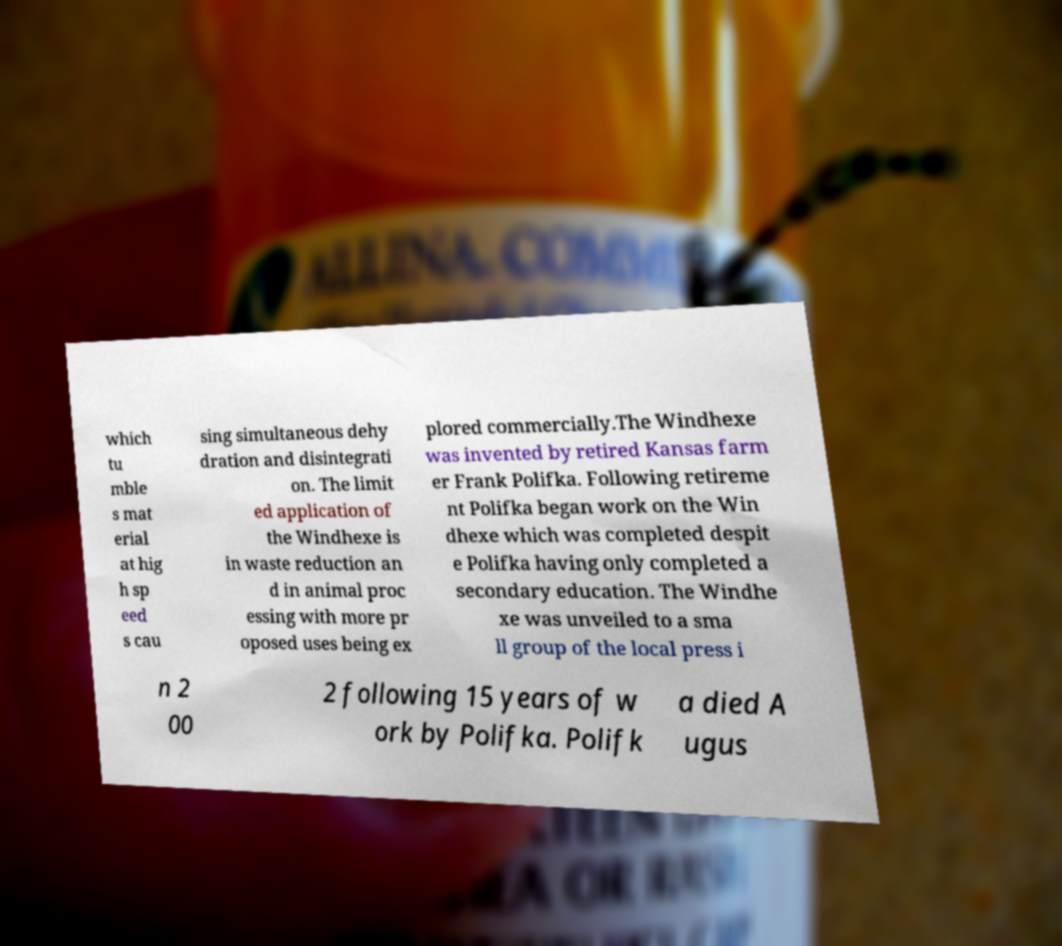There's text embedded in this image that I need extracted. Can you transcribe it verbatim? which tu mble s mat erial at hig h sp eed s cau sing simultaneous dehy dration and disintegrati on. The limit ed application of the Windhexe is in waste reduction an d in animal proc essing with more pr oposed uses being ex plored commercially.The Windhexe was invented by retired Kansas farm er Frank Polifka. Following retireme nt Polifka began work on the Win dhexe which was completed despit e Polifka having only completed a secondary education. The Windhe xe was unveiled to a sma ll group of the local press i n 2 00 2 following 15 years of w ork by Polifka. Polifk a died A ugus 